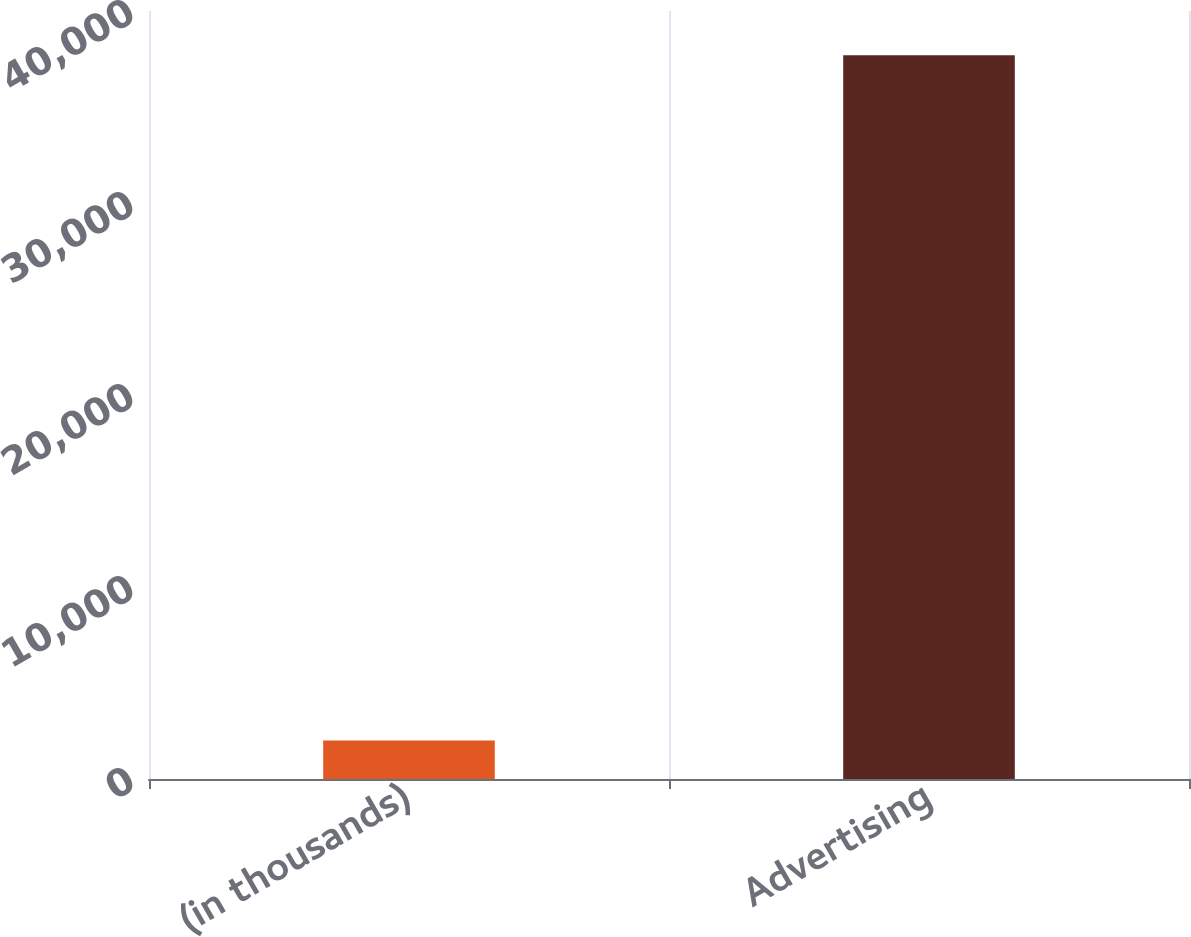Convert chart. <chart><loc_0><loc_0><loc_500><loc_500><bar_chart><fcel>(in thousands)<fcel>Advertising<nl><fcel>2007<fcel>37699<nl></chart> 